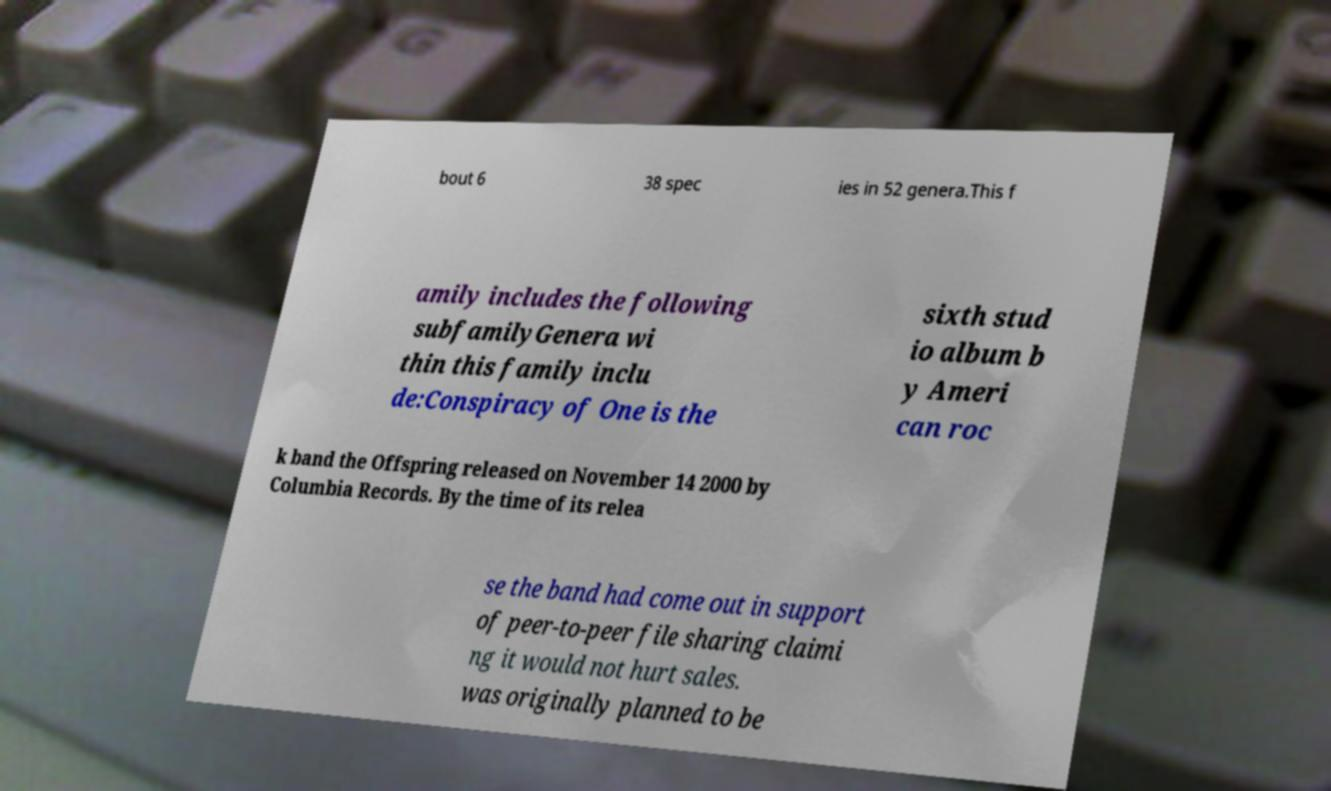I need the written content from this picture converted into text. Can you do that? bout 6 38 spec ies in 52 genera.This f amily includes the following subfamilyGenera wi thin this family inclu de:Conspiracy of One is the sixth stud io album b y Ameri can roc k band the Offspring released on November 14 2000 by Columbia Records. By the time of its relea se the band had come out in support of peer-to-peer file sharing claimi ng it would not hurt sales. was originally planned to be 